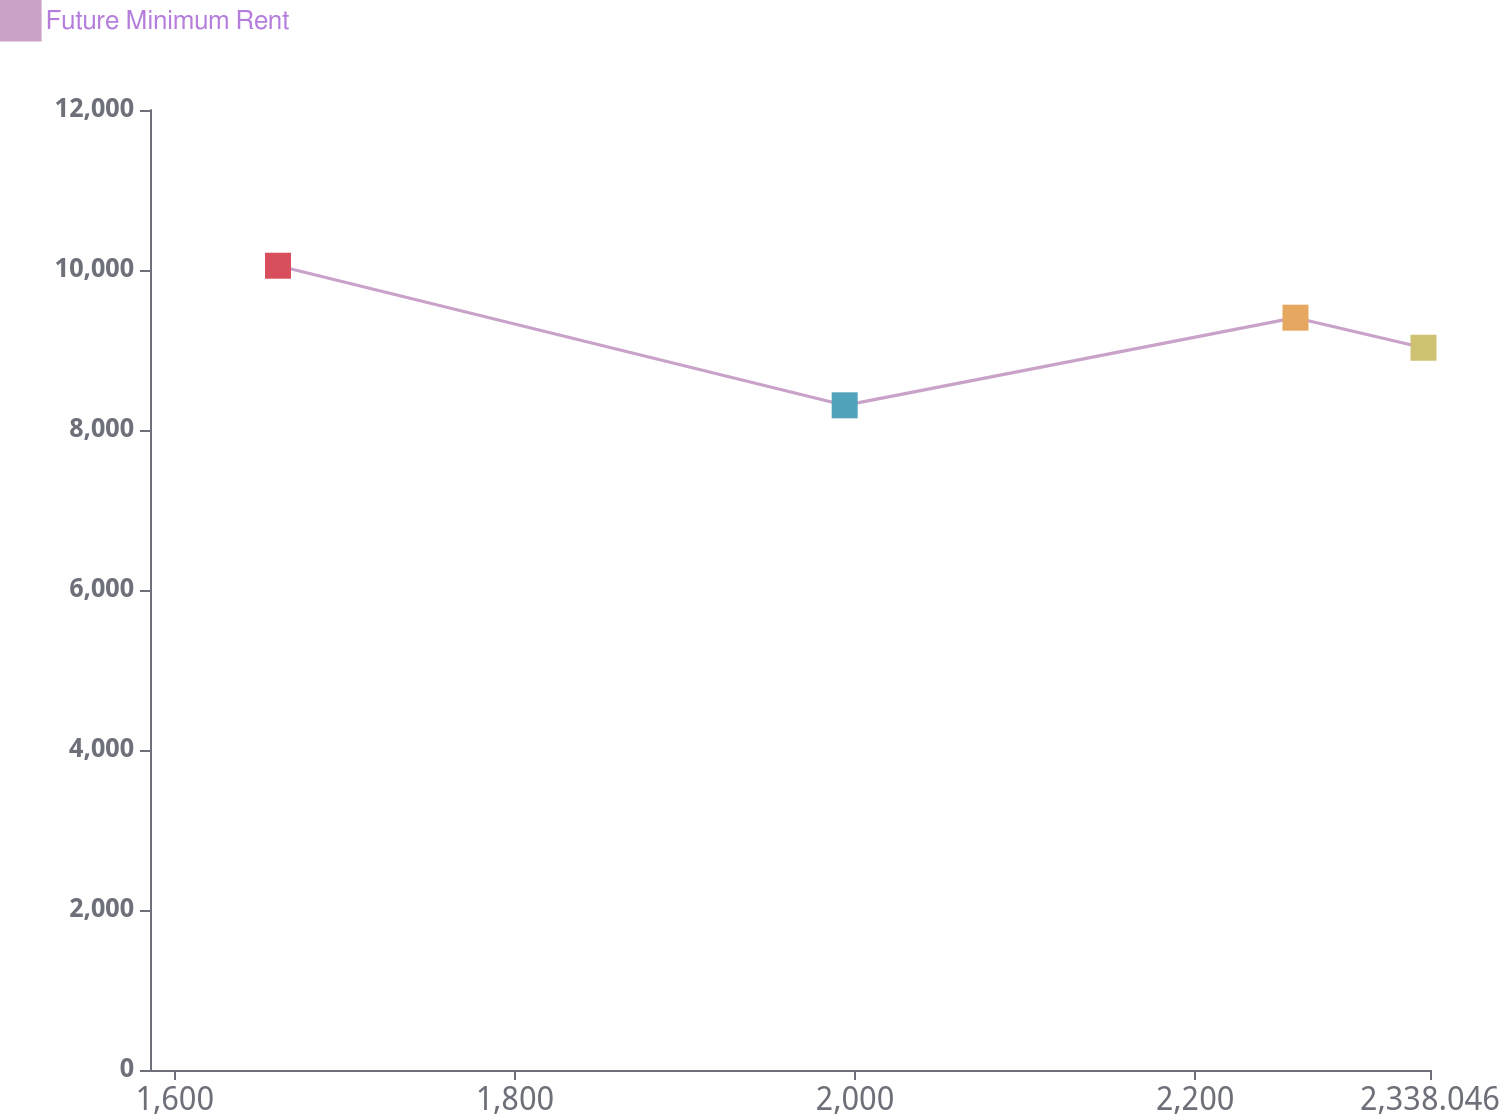Convert chart. <chart><loc_0><loc_0><loc_500><loc_500><line_chart><ecel><fcel>Future Minimum Rent<nl><fcel>1660.67<fcel>10053.4<nl><fcel>1993.88<fcel>8308.54<nl><fcel>2258.95<fcel>9403.93<nl><fcel>2334.21<fcel>9028.21<nl><fcel>2413.31<fcel>8779<nl></chart> 